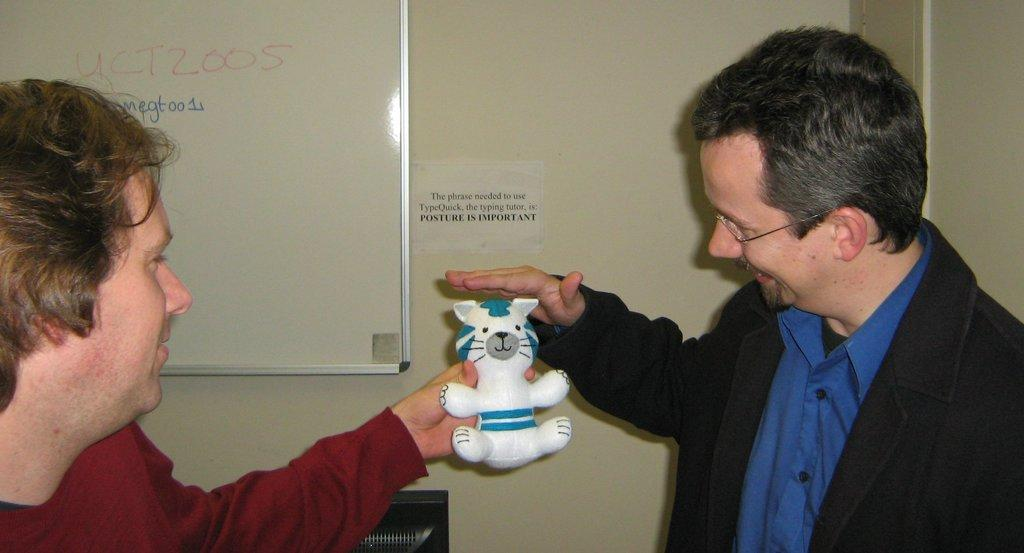What is happening in the image? There are people standing in the image. Can you describe what one of the people is holding? A person is holding a toy in his hand. What can be seen in the background of the image? There is a wall in the background of the image. What is on the wall? There is a whiteboard on the wall. How many cows can be seen grazing in the background of the image? There are no cows present in the image; it features people standing and a wall with a whiteboard in the background. 